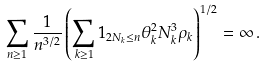Convert formula to latex. <formula><loc_0><loc_0><loc_500><loc_500>\sum _ { n \geq 1 } \frac { 1 } { n ^ { 3 / 2 } } \left ( \sum _ { k \geq 1 } { 1 } _ { 2 N _ { k } \leq n } \theta _ { k } ^ { 2 } N _ { k } ^ { 3 } \rho _ { k } \right ) ^ { 1 / 2 } = \infty \, .</formula> 